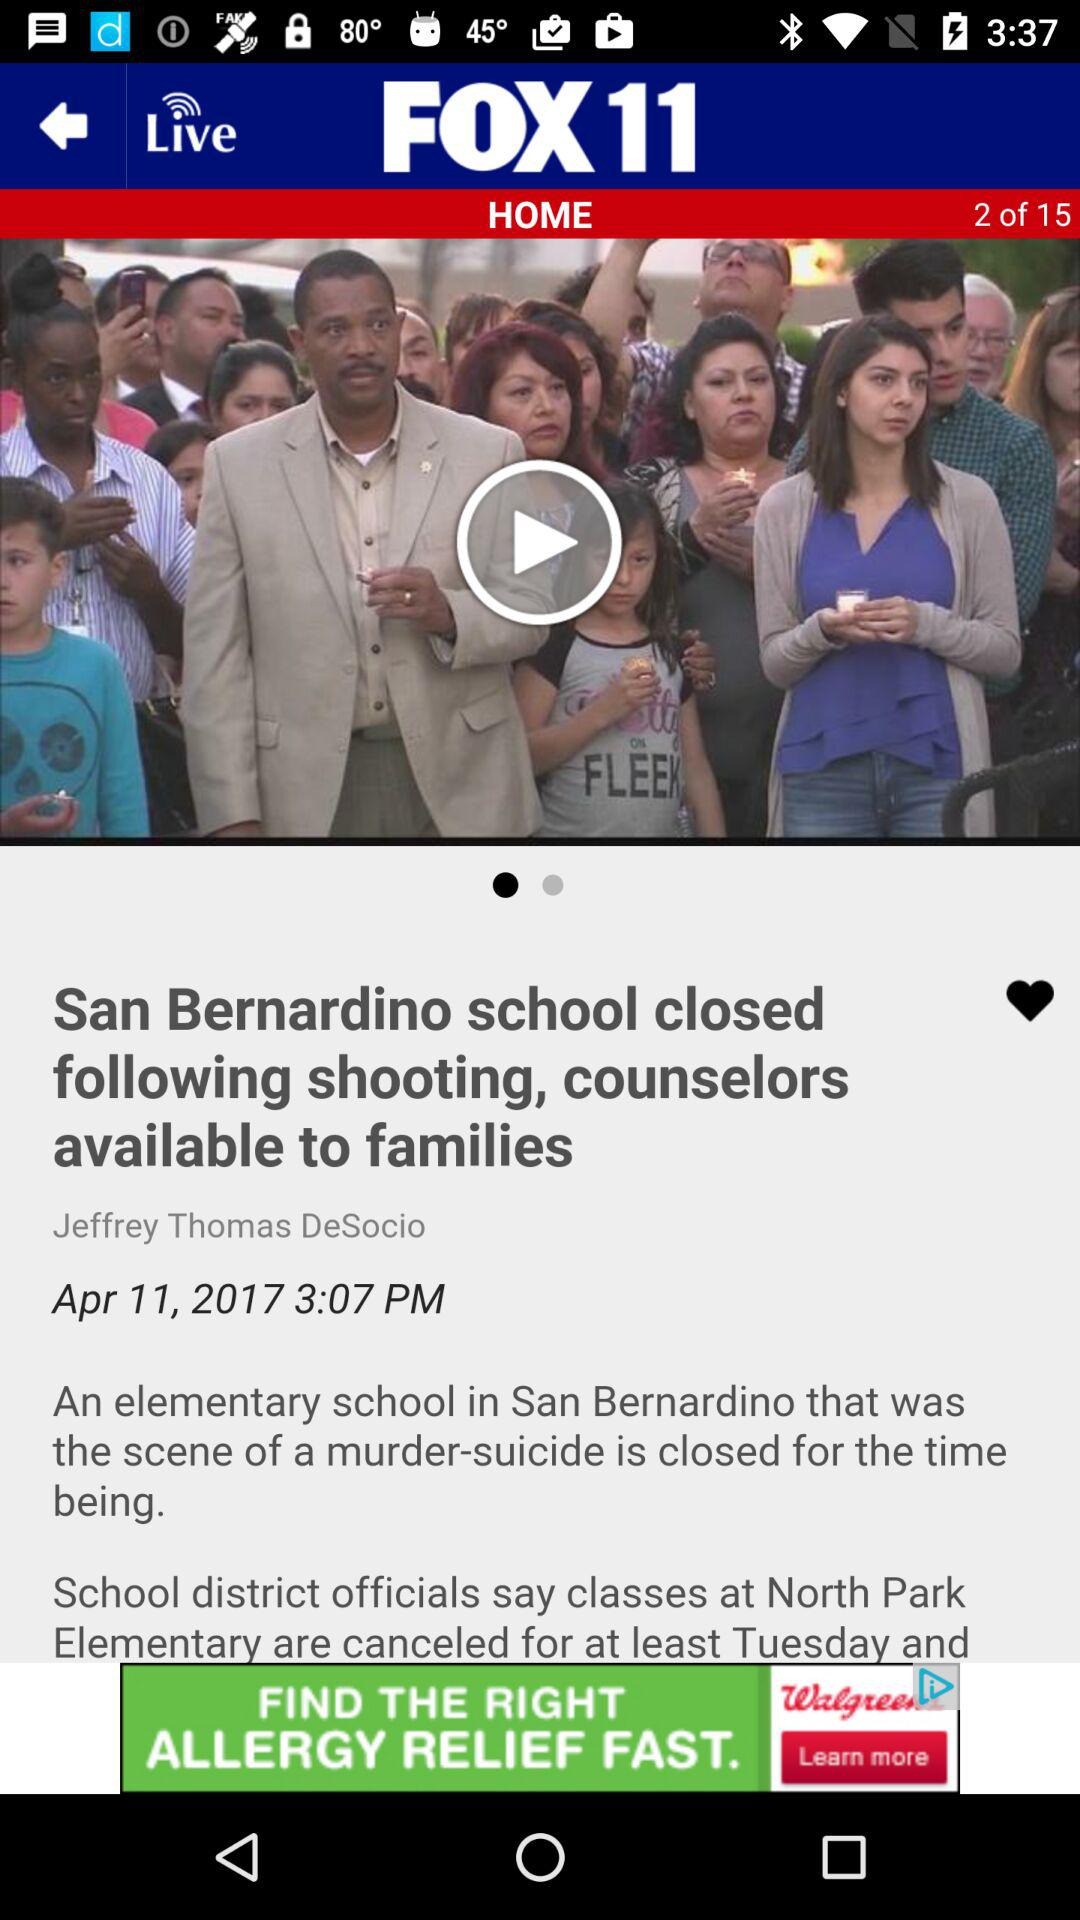How many total articles are there? There are a total of 15 articles. 